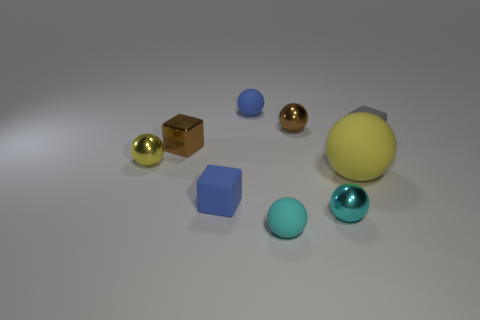Subtract all brown spheres. How many spheres are left? 5 Subtract all brown shiny spheres. How many spheres are left? 5 Subtract all red spheres. Subtract all cyan cylinders. How many spheres are left? 6 Add 1 brown metallic spheres. How many objects exist? 10 Subtract all blocks. How many objects are left? 6 Add 2 small cyan rubber things. How many small cyan rubber things are left? 3 Add 5 green rubber cylinders. How many green rubber cylinders exist? 5 Subtract 1 yellow spheres. How many objects are left? 8 Subtract all brown spheres. Subtract all small rubber objects. How many objects are left? 4 